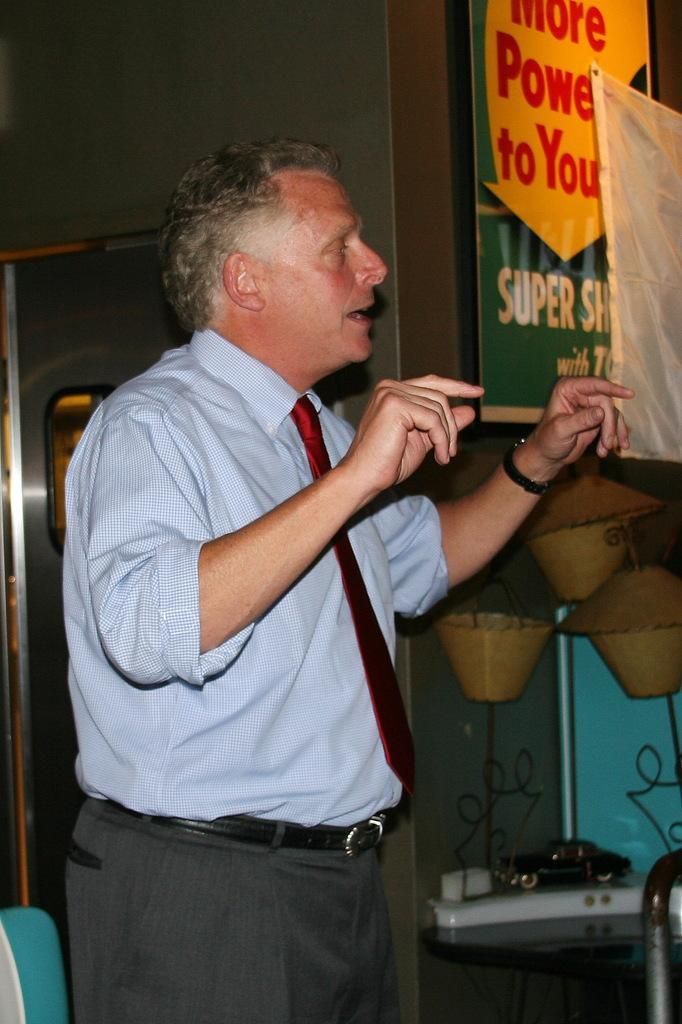<image>
Offer a succinct explanation of the picture presented. A banner to the right of the man reads more power to you. 